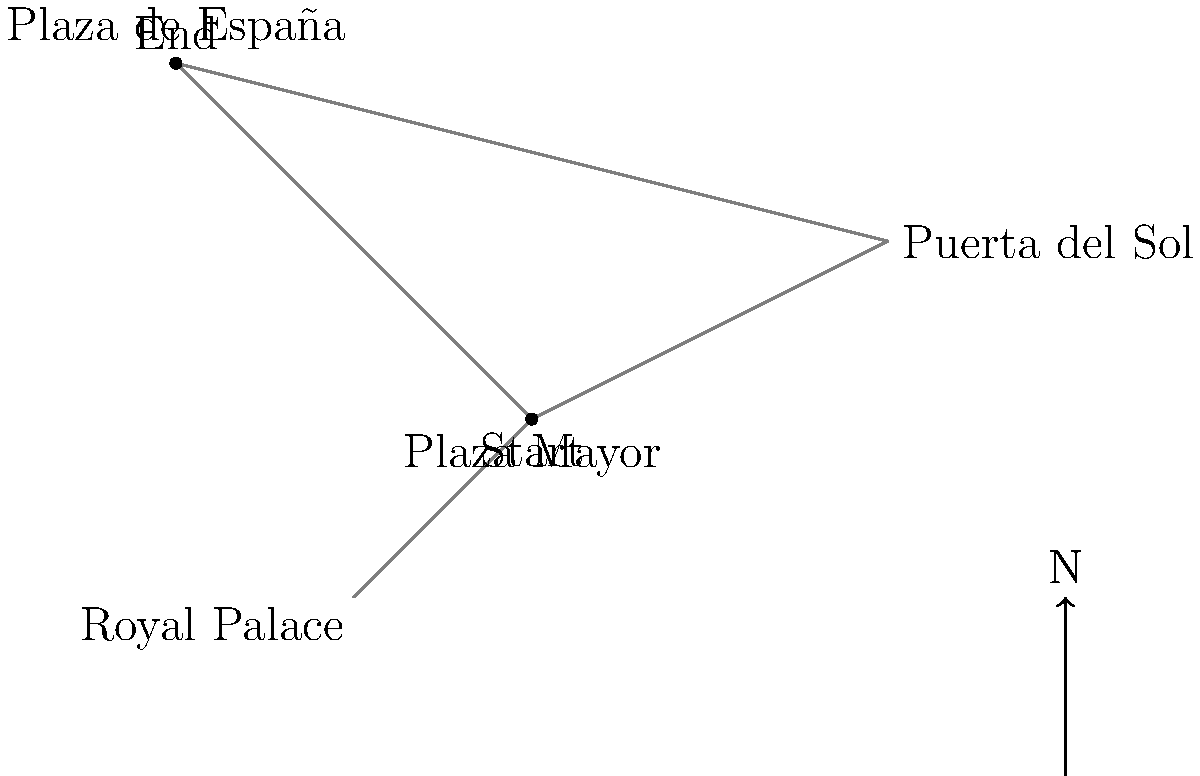Starting from Plaza Mayor, you need to navigate to Plaza de España. What is the minimum number of street segments you must traverse to reach your destination, assuming you can only travel along the marked streets? To solve this spatial awareness question, let's follow these steps:

1. Identify the starting point (Plaza Mayor) and the destination (Plaza de España).

2. Observe the available routes on the map:
   a) Plaza Mayor to Puerta del Sol
   b) Plaza Mayor to Royal Palace
   c) Plaza Mayor directly to Plaza de España
   d) Puerta del Sol to Plaza de España

3. Analyze the possible paths:
   - Direct route: Plaza Mayor to Plaza de España (1 segment)
   - Indirect route: Plaza Mayor to Puerta del Sol to Plaza de España (2 segments)

4. Compare the number of street segments for each route:
   - Direct route: 1 segment
   - Indirect route: 2 segments

5. Choose the route with the minimum number of street segments.

The direct route from Plaza Mayor to Plaza de España requires traversing only one street segment, which is the minimum possible.
Answer: 1 